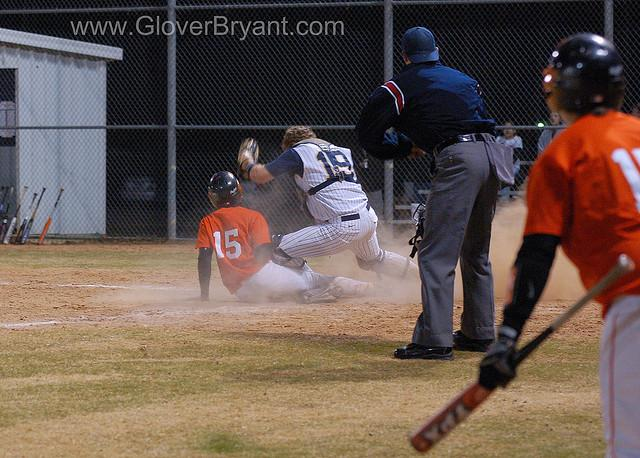What action caused the dust to fly? slide 